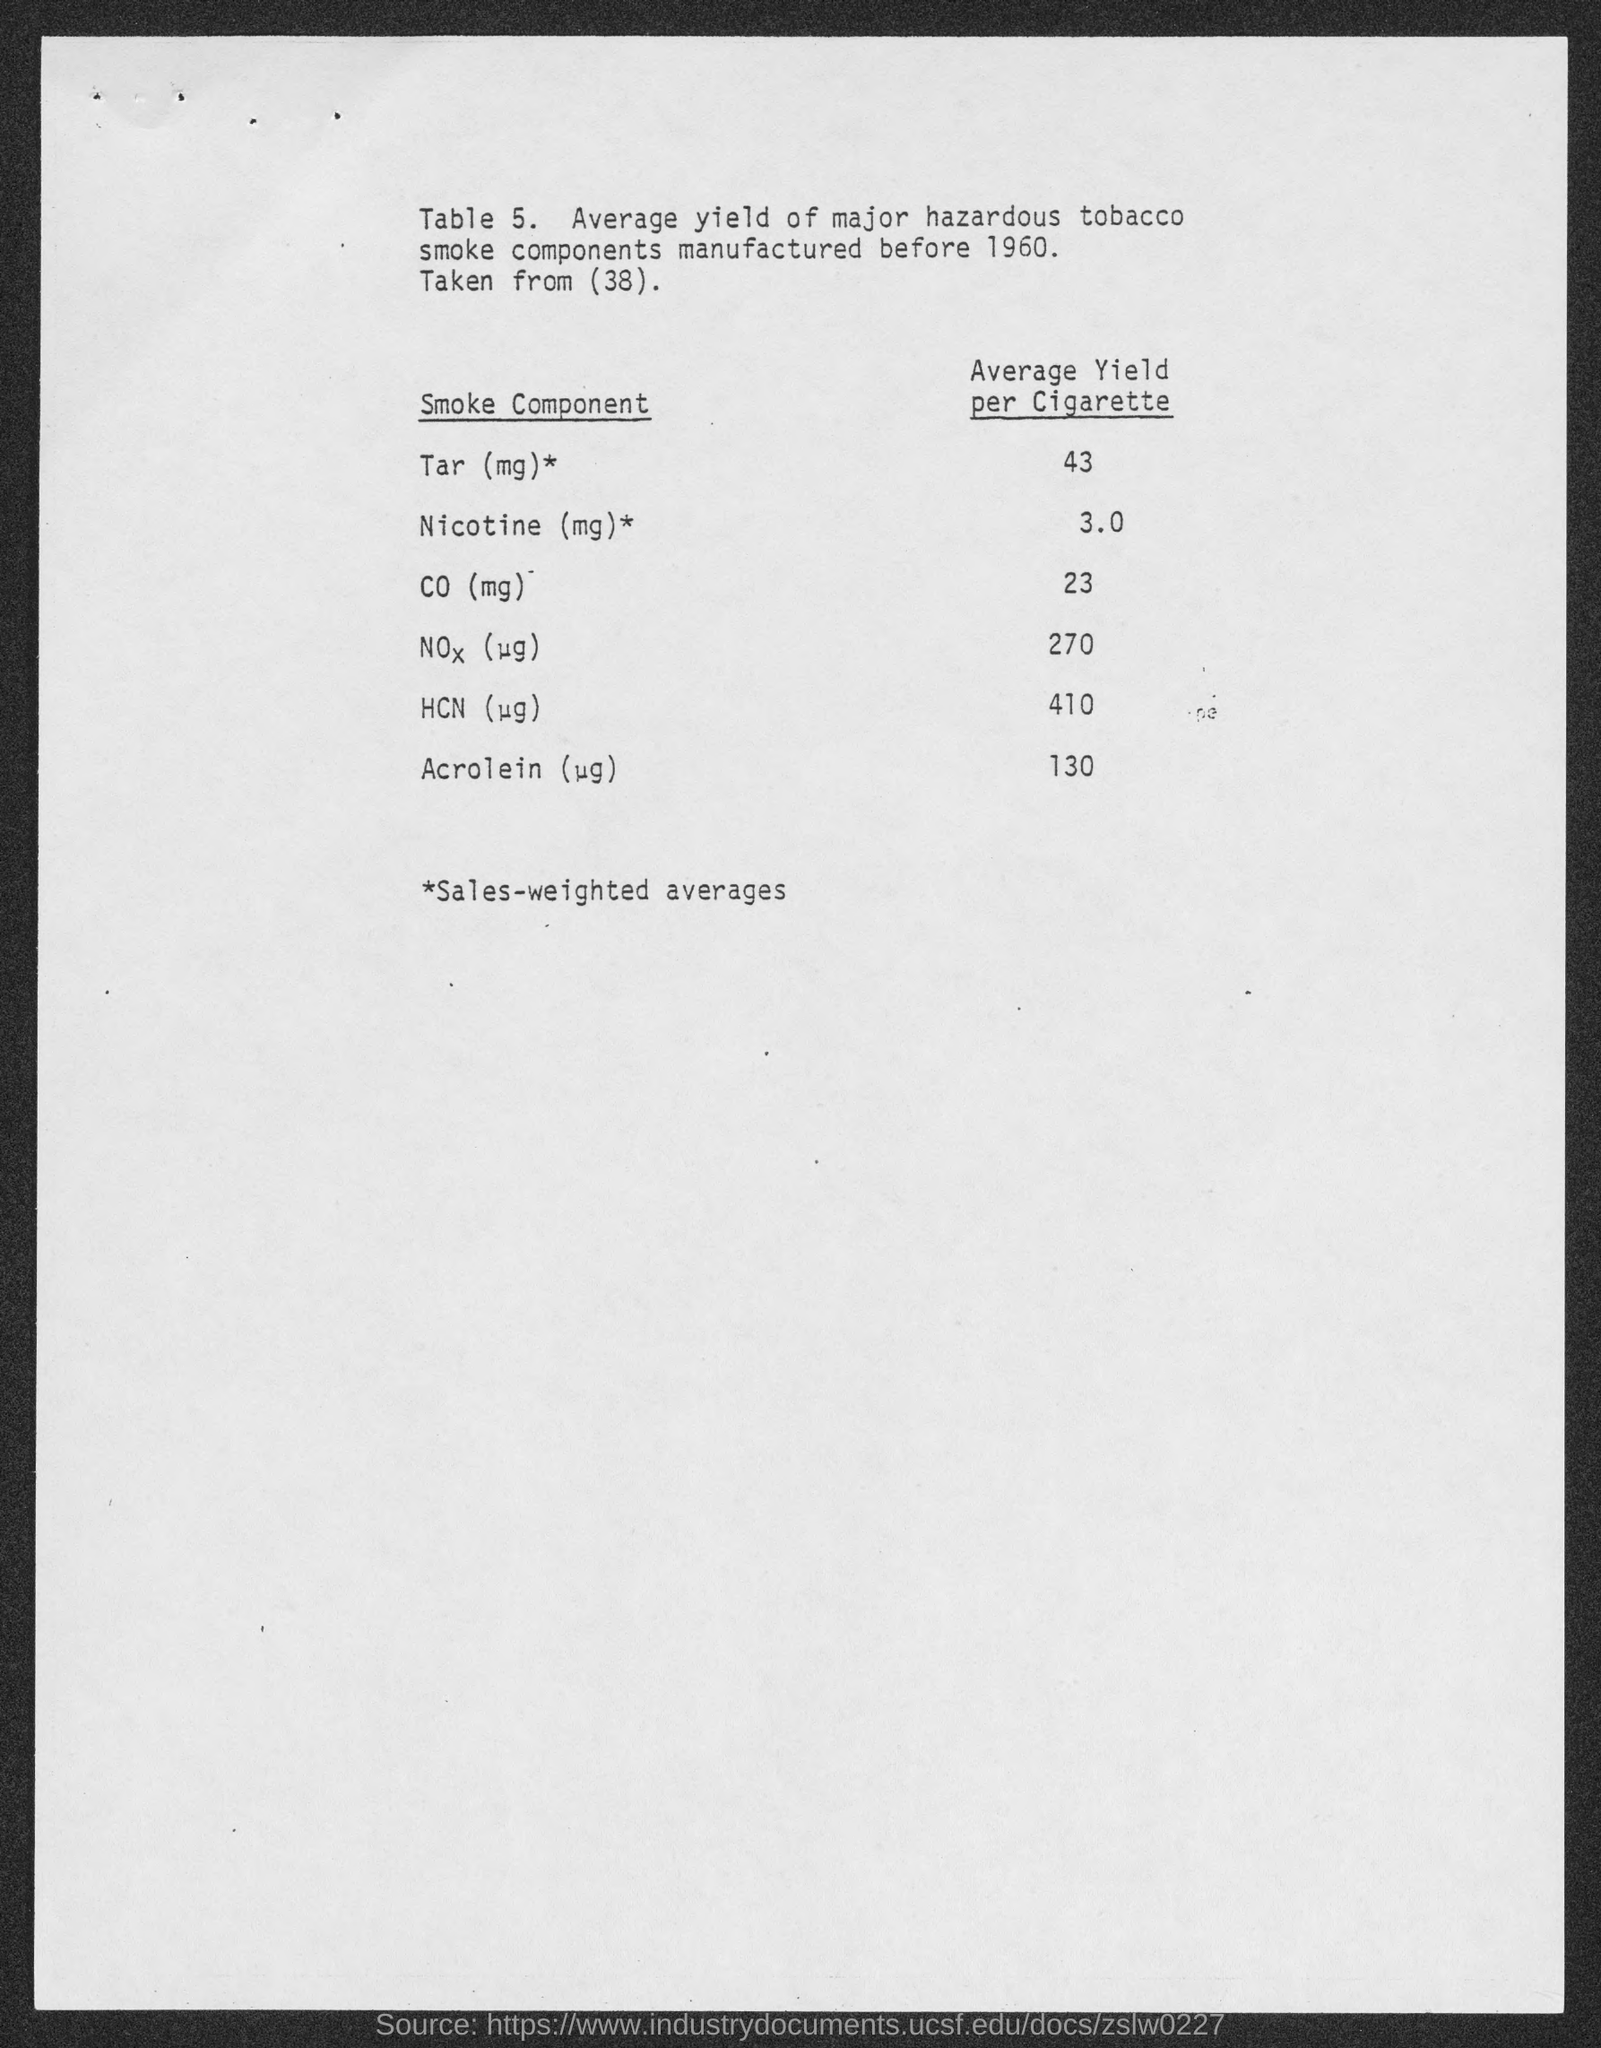What is the average yield of Tar (mg) per cigarette manufactured before 1960?
Offer a very short reply. 43. What is the average yield of CO (mg) per cigarette manufactured before 1960?
Make the answer very short. 23. What does Table 5. describe about?
Your response must be concise. Average yield of major hazardous tobacco smoke components manufactured before 1960. 